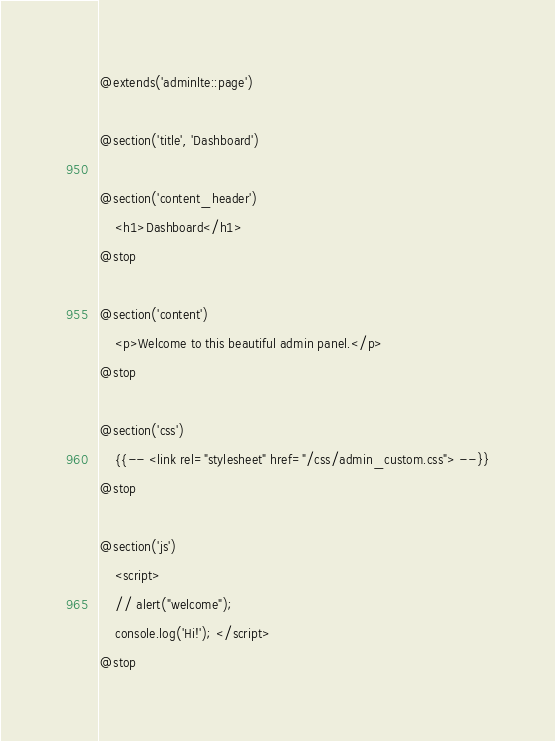<code> <loc_0><loc_0><loc_500><loc_500><_PHP_>@extends('adminlte::page')

@section('title', 'Dashboard')

@section('content_header')
    <h1>Dashboard</h1>
@stop

@section('content')
    <p>Welcome to this beautiful admin panel.</p>
@stop

@section('css')
    {{-- <link rel="stylesheet" href="/css/admin_custom.css"> --}}
@stop

@section('js')
    <script>
    // alert("welcome");
    console.log('Hi!'); </script>
@stop
</code> 